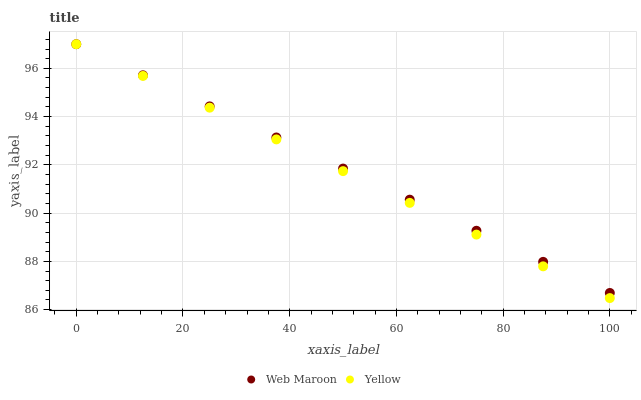Does Yellow have the minimum area under the curve?
Answer yes or no. Yes. Does Web Maroon have the maximum area under the curve?
Answer yes or no. Yes. Does Yellow have the maximum area under the curve?
Answer yes or no. No. Is Web Maroon the smoothest?
Answer yes or no. Yes. Is Yellow the roughest?
Answer yes or no. Yes. Is Yellow the smoothest?
Answer yes or no. No. Does Yellow have the lowest value?
Answer yes or no. Yes. Does Yellow have the highest value?
Answer yes or no. Yes. Does Yellow intersect Web Maroon?
Answer yes or no. Yes. Is Yellow less than Web Maroon?
Answer yes or no. No. Is Yellow greater than Web Maroon?
Answer yes or no. No. 